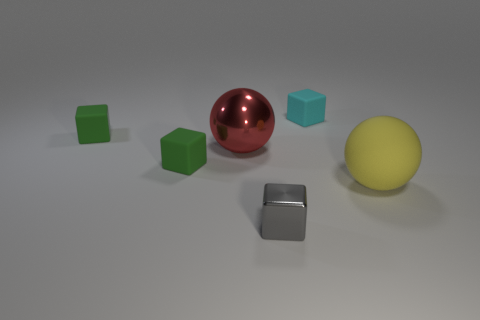What number of things are right of the big red thing and in front of the tiny cyan cube? There is one yellow sphere positioned to the right of the big red sphere and in front of the tiny cyan cube. 